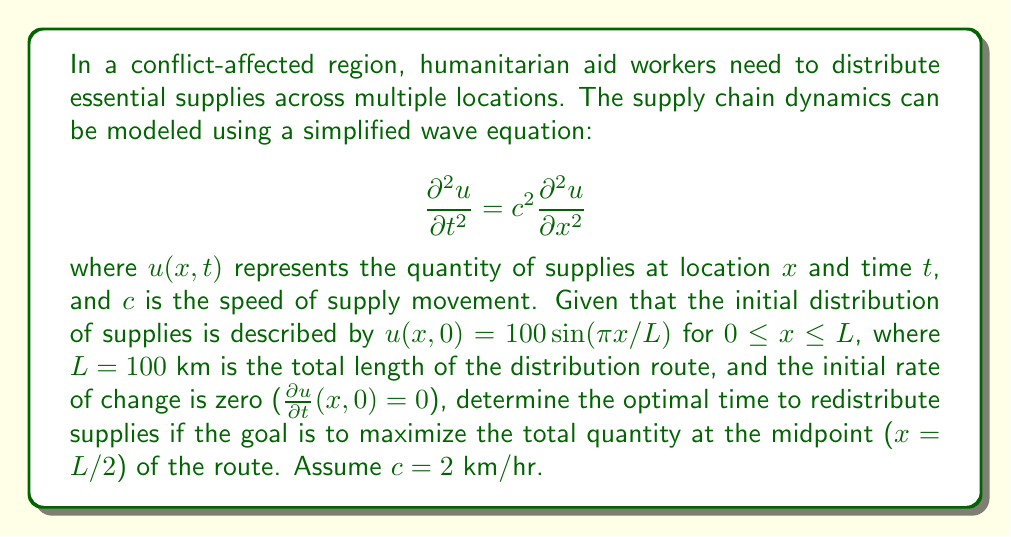Give your solution to this math problem. To solve this problem, we'll follow these steps:

1) The general solution to the wave equation with the given initial conditions is:

   $$u(x,t) = 50[\sin(\pi x/L - \pi ct/L) + \sin(\pi x/L + \pi ct/L)]$$

2) At the midpoint of the route, $x = L/2 = 50$ km. Substituting this into the equation:

   $$u(50,t) = 50[\sin(\pi/2 - \pi ct/L) + \sin(\pi/2 + \pi ct/L)]$$

3) Using trigonometric identities, this simplifies to:

   $$u(50,t) = 100 \cos(\pi ct/L)$$

4) To find the maximum value, we need to find when $\cos(\pi ct/L)$ equals 1. This occurs when:

   $$\pi ct/L = 2\pi n$$, where $n$ is an integer.

5) Solving for $t$:

   $$t = \frac{2Ln}{c}$$

6) The first maximum (smallest positive $t$) occurs when $n = 1$:

   $$t = \frac{2L}{c} = \frac{2(100)}{2} = 100$$ hours

Therefore, the optimal time to redistribute supplies to maximize the quantity at the midpoint is 100 hours after the initial distribution.
Answer: 100 hours 